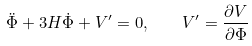Convert formula to latex. <formula><loc_0><loc_0><loc_500><loc_500>\ddot { \Phi } + 3 H \dot { \Phi } + V ^ { \prime } = 0 , \quad V ^ { \prime } = \frac { \partial V } { \partial \Phi }</formula> 